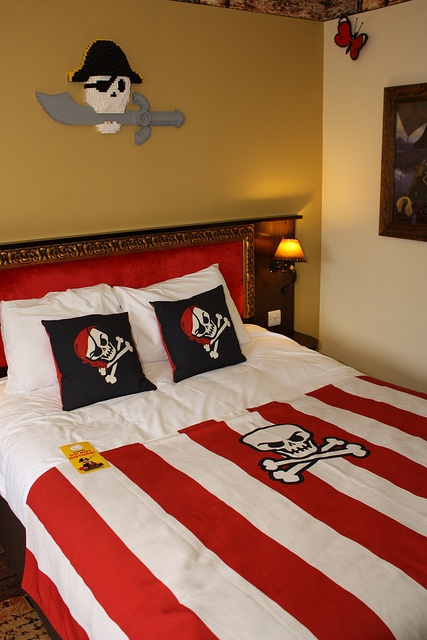Describe the objects in this image and their specific colors. I can see a bed in olive, maroon, tan, and lightgray tones in this image. 